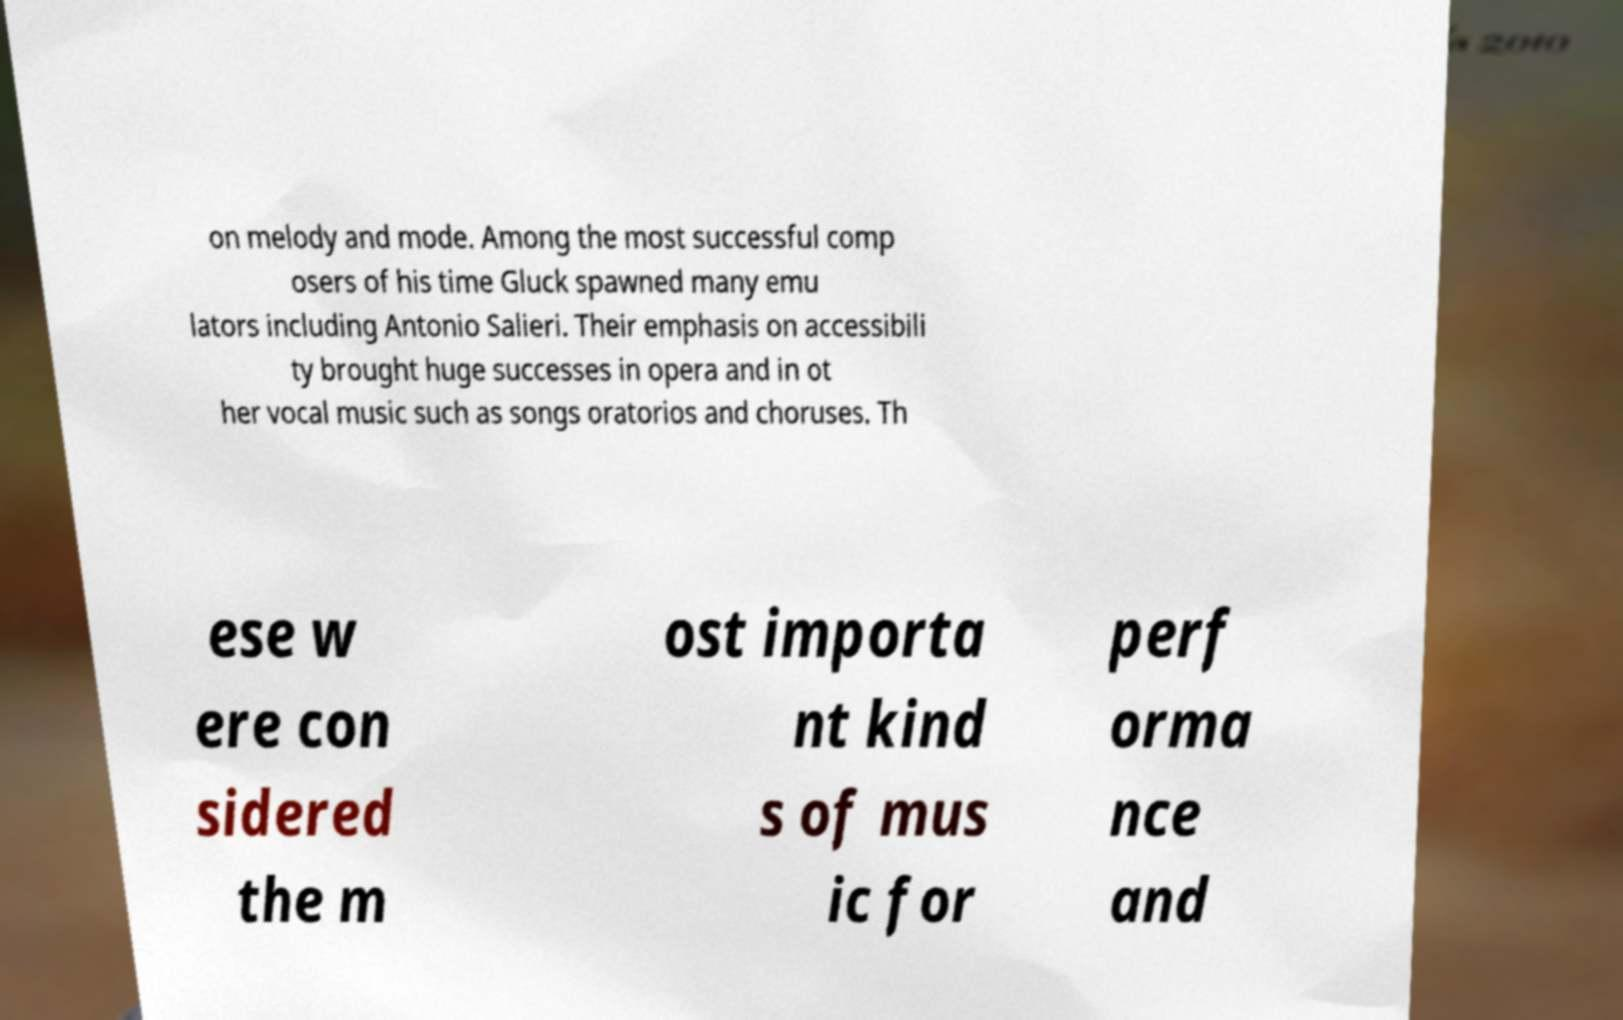Could you extract and type out the text from this image? on melody and mode. Among the most successful comp osers of his time Gluck spawned many emu lators including Antonio Salieri. Their emphasis on accessibili ty brought huge successes in opera and in ot her vocal music such as songs oratorios and choruses. Th ese w ere con sidered the m ost importa nt kind s of mus ic for perf orma nce and 